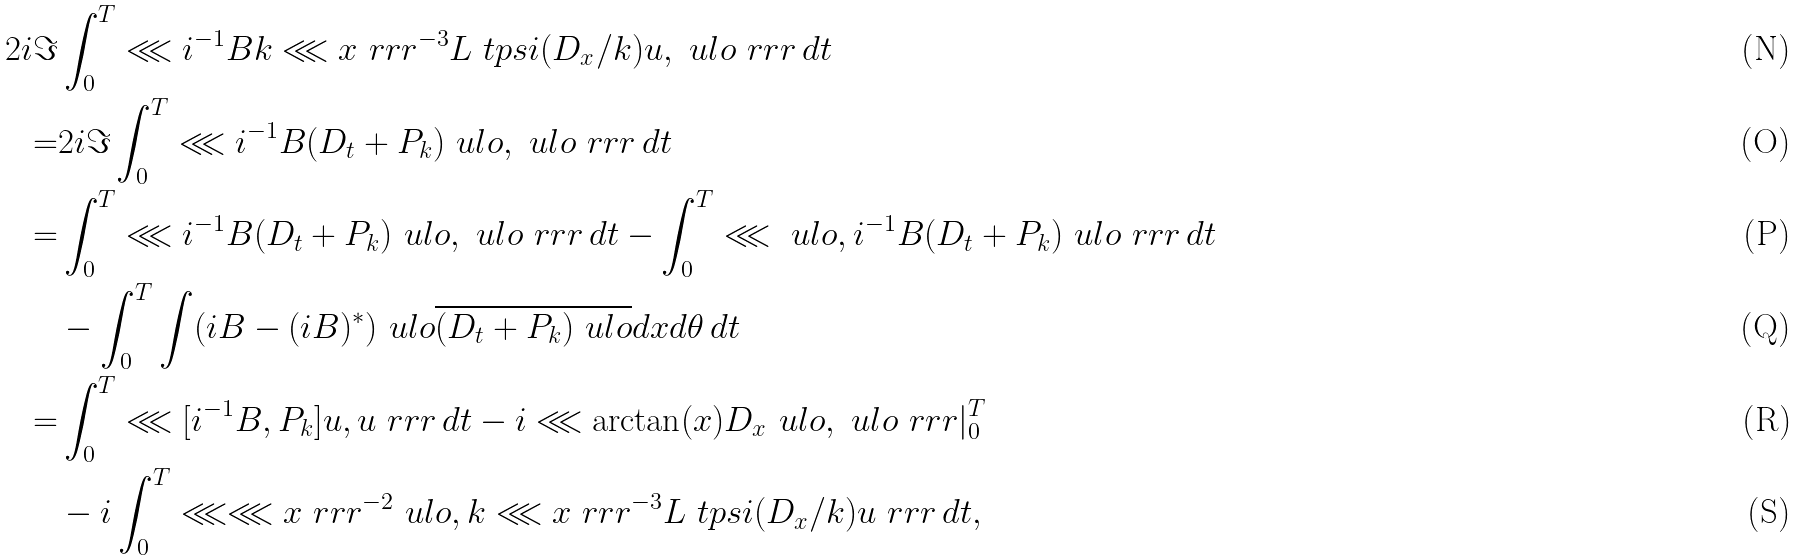Convert formula to latex. <formula><loc_0><loc_0><loc_500><loc_500>2 i \Im & \int _ { 0 } ^ { T } \lll i ^ { - 1 } B k \lll x \ r r r ^ { - 3 } L \ t p s i ( D _ { x } / k ) u , \ u l o \ r r r \, d t \\ = & 2 i \Im \int _ { 0 } ^ { T } \lll i ^ { - 1 } B ( D _ { t } + P _ { k } ) \ u l o , \ u l o \ r r r \, d t \\ = & \int _ { 0 } ^ { T } \lll i ^ { - 1 } B ( D _ { t } + P _ { k } ) \ u l o , \ u l o \ r r r \, d t - \int _ { 0 } ^ { T } \lll \ u l o , i ^ { - 1 } B ( D _ { t } + P _ { k } ) \ u l o \ r r r \, d t \\ & - \int _ { 0 } ^ { T } \int ( i B - ( i B ) ^ { * } ) \ u l o \overline { ( D _ { t } + P _ { k } ) \ u l o } d x d \theta \, d t \\ = & \int _ { 0 } ^ { T } \lll [ i ^ { - 1 } B , P _ { k } ] u , u \ r r r \, d t - i \lll \arctan ( x ) D _ { x } \ u l o , \ u l o \ r r r | _ { 0 } ^ { T } \\ & - i \int _ { 0 } ^ { T } \lll \lll x \ r r r ^ { - 2 } \ u l o , k \lll x \ r r r ^ { - 3 } L \ t p s i ( D _ { x } / k ) u \ r r r \, d t ,</formula> 